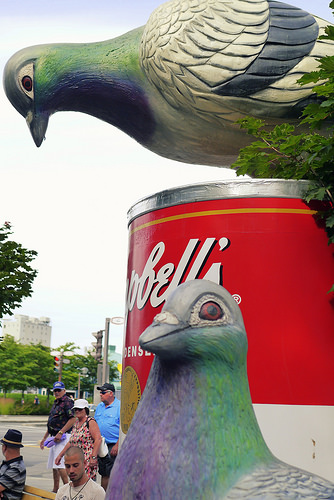<image>
Can you confirm if the pigeon sculpture is on the soup sculpture? Yes. Looking at the image, I can see the pigeon sculpture is positioned on top of the soup sculpture, with the soup sculpture providing support. Where is the bird in relation to the can? Is it next to the can? Yes. The bird is positioned adjacent to the can, located nearby in the same general area. 